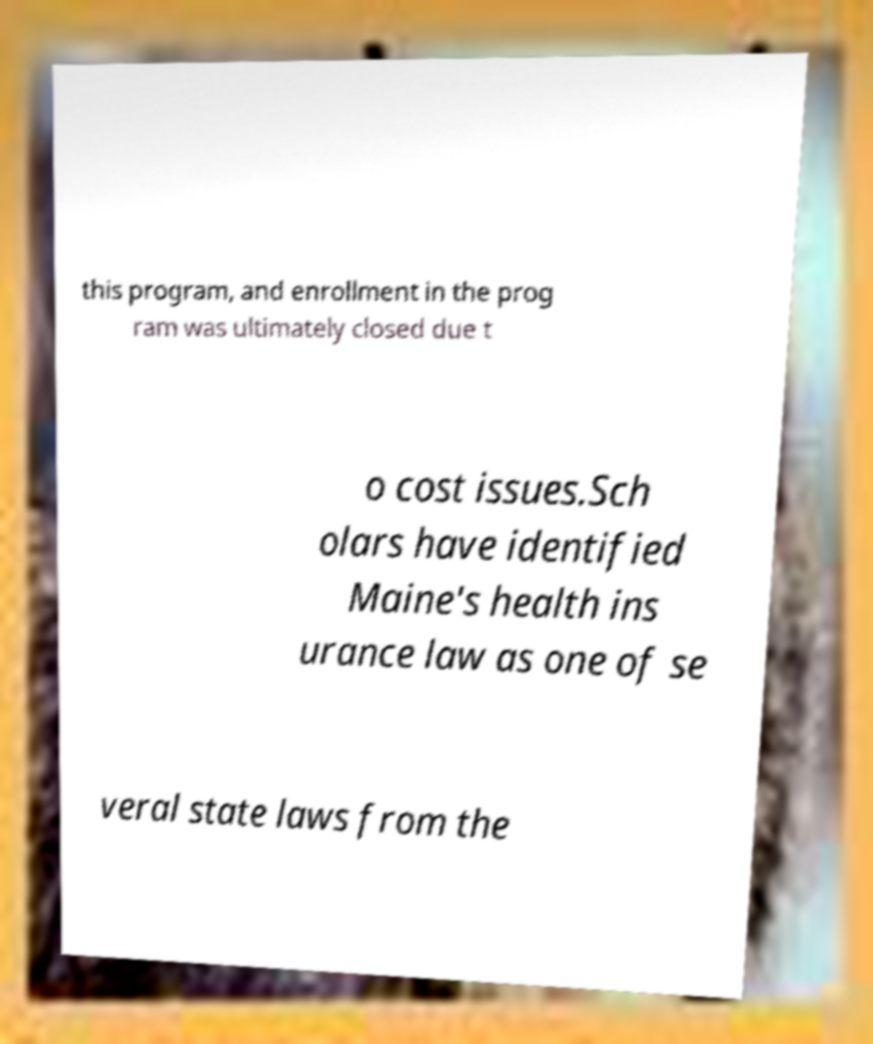I need the written content from this picture converted into text. Can you do that? this program, and enrollment in the prog ram was ultimately closed due t o cost issues.Sch olars have identified Maine's health ins urance law as one of se veral state laws from the 